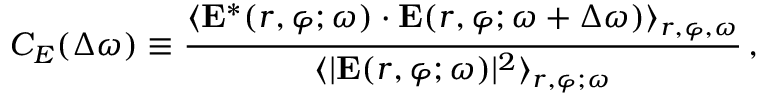<formula> <loc_0><loc_0><loc_500><loc_500>C _ { E } ( \Delta \omega ) \equiv \frac { \langle { E } ^ { * } ( r , \varphi ; \omega ) \cdot { E } ( r , \varphi ; \omega + \Delta \omega ) \rangle _ { r , \varphi , \omega } } { \langle | { E } ( r , \varphi ; \omega ) | ^ { 2 } \rangle _ { r , \varphi ; \omega } } \, ,</formula> 